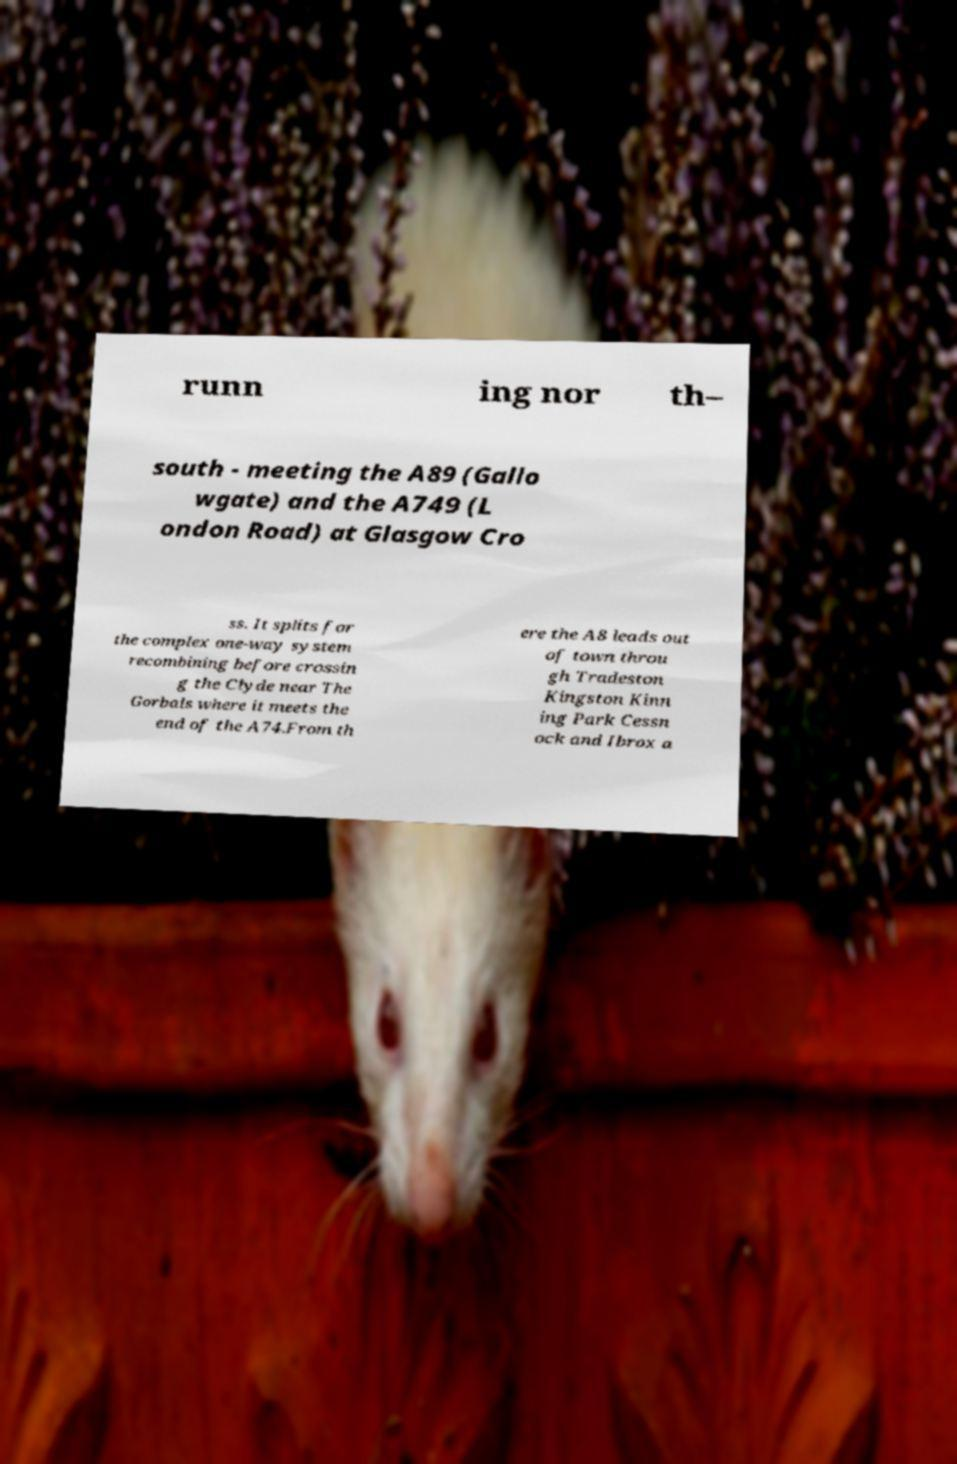For documentation purposes, I need the text within this image transcribed. Could you provide that? runn ing nor th– south - meeting the A89 (Gallo wgate) and the A749 (L ondon Road) at Glasgow Cro ss. It splits for the complex one-way system recombining before crossin g the Clyde near The Gorbals where it meets the end of the A74.From th ere the A8 leads out of town throu gh Tradeston Kingston Kinn ing Park Cessn ock and Ibrox a 